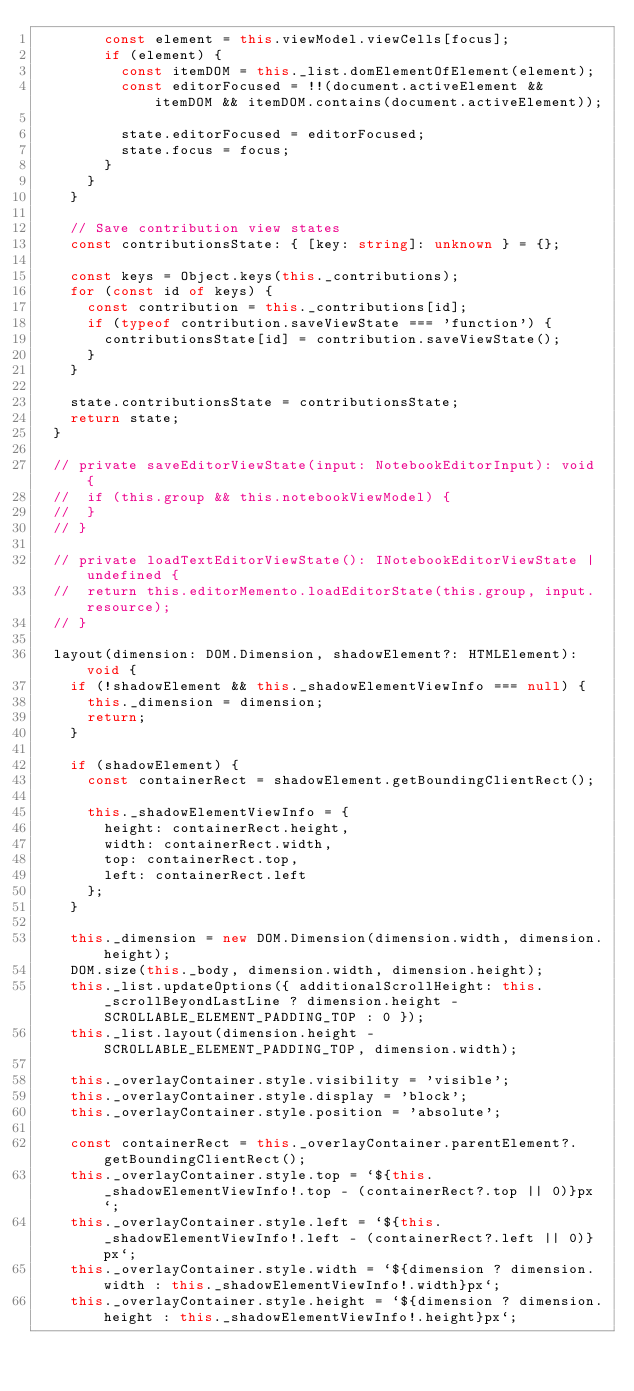<code> <loc_0><loc_0><loc_500><loc_500><_TypeScript_>				const element = this.viewModel.viewCells[focus];
				if (element) {
					const itemDOM = this._list.domElementOfElement(element);
					const editorFocused = !!(document.activeElement && itemDOM && itemDOM.contains(document.activeElement));

					state.editorFocused = editorFocused;
					state.focus = focus;
				}
			}
		}

		// Save contribution view states
		const contributionsState: { [key: string]: unknown } = {};

		const keys = Object.keys(this._contributions);
		for (const id of keys) {
			const contribution = this._contributions[id];
			if (typeof contribution.saveViewState === 'function') {
				contributionsState[id] = contribution.saveViewState();
			}
		}

		state.contributionsState = contributionsState;
		return state;
	}

	// private saveEditorViewState(input: NotebookEditorInput): void {
	// 	if (this.group && this.notebookViewModel) {
	// 	}
	// }

	// private loadTextEditorViewState(): INotebookEditorViewState | undefined {
	// 	return this.editorMemento.loadEditorState(this.group, input.resource);
	// }

	layout(dimension: DOM.Dimension, shadowElement?: HTMLElement): void {
		if (!shadowElement && this._shadowElementViewInfo === null) {
			this._dimension = dimension;
			return;
		}

		if (shadowElement) {
			const containerRect = shadowElement.getBoundingClientRect();

			this._shadowElementViewInfo = {
				height: containerRect.height,
				width: containerRect.width,
				top: containerRect.top,
				left: containerRect.left
			};
		}

		this._dimension = new DOM.Dimension(dimension.width, dimension.height);
		DOM.size(this._body, dimension.width, dimension.height);
		this._list.updateOptions({ additionalScrollHeight: this._scrollBeyondLastLine ? dimension.height - SCROLLABLE_ELEMENT_PADDING_TOP : 0 });
		this._list.layout(dimension.height - SCROLLABLE_ELEMENT_PADDING_TOP, dimension.width);

		this._overlayContainer.style.visibility = 'visible';
		this._overlayContainer.style.display = 'block';
		this._overlayContainer.style.position = 'absolute';

		const containerRect = this._overlayContainer.parentElement?.getBoundingClientRect();
		this._overlayContainer.style.top = `${this._shadowElementViewInfo!.top - (containerRect?.top || 0)}px`;
		this._overlayContainer.style.left = `${this._shadowElementViewInfo!.left - (containerRect?.left || 0)}px`;
		this._overlayContainer.style.width = `${dimension ? dimension.width : this._shadowElementViewInfo!.width}px`;
		this._overlayContainer.style.height = `${dimension ? dimension.height : this._shadowElementViewInfo!.height}px`;
</code> 